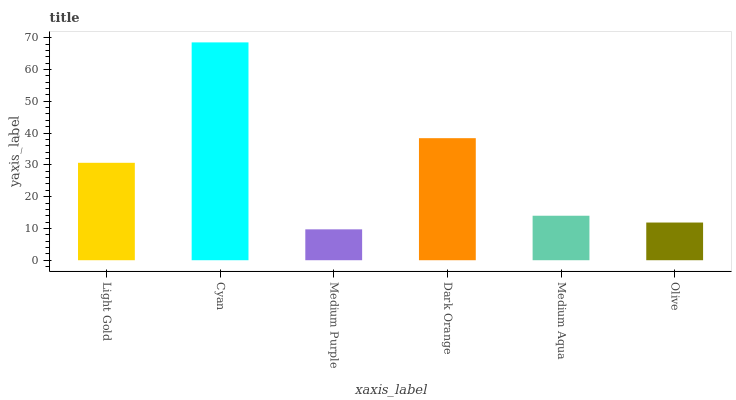Is Medium Purple the minimum?
Answer yes or no. Yes. Is Cyan the maximum?
Answer yes or no. Yes. Is Cyan the minimum?
Answer yes or no. No. Is Medium Purple the maximum?
Answer yes or no. No. Is Cyan greater than Medium Purple?
Answer yes or no. Yes. Is Medium Purple less than Cyan?
Answer yes or no. Yes. Is Medium Purple greater than Cyan?
Answer yes or no. No. Is Cyan less than Medium Purple?
Answer yes or no. No. Is Light Gold the high median?
Answer yes or no. Yes. Is Medium Aqua the low median?
Answer yes or no. Yes. Is Olive the high median?
Answer yes or no. No. Is Dark Orange the low median?
Answer yes or no. No. 